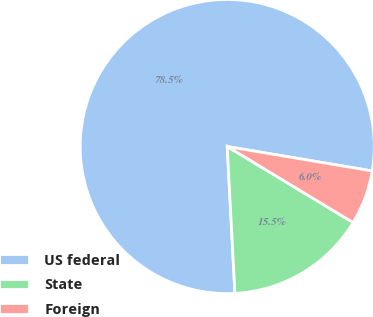<chart> <loc_0><loc_0><loc_500><loc_500><pie_chart><fcel>US federal<fcel>State<fcel>Foreign<nl><fcel>78.49%<fcel>15.52%<fcel>5.99%<nl></chart> 